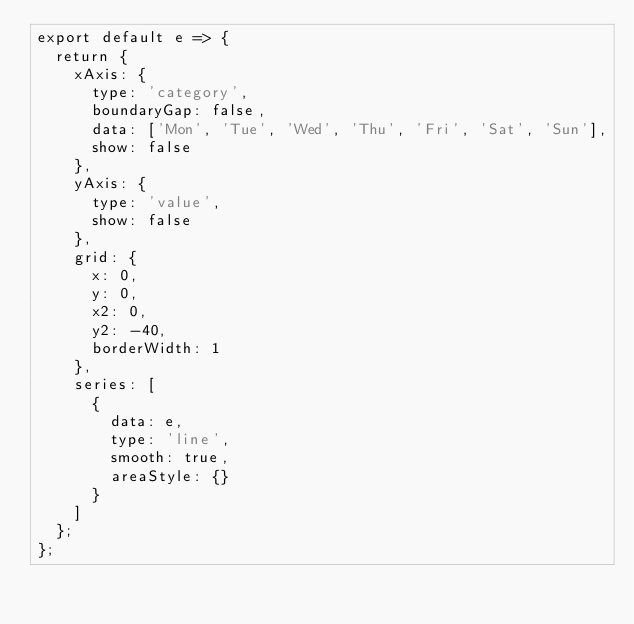Convert code to text. <code><loc_0><loc_0><loc_500><loc_500><_JavaScript_>export default e => {
  return {
    xAxis: {
      type: 'category',
      boundaryGap: false,
      data: ['Mon', 'Tue', 'Wed', 'Thu', 'Fri', 'Sat', 'Sun'],
      show: false
    },
    yAxis: {
      type: 'value',
      show: false
    },
    grid: {
      x: 0,
      y: 0,
      x2: 0,
      y2: -40,
      borderWidth: 1
    },
    series: [
      {
        data: e,
        type: 'line',
        smooth: true,
        areaStyle: {}
      }
    ]
  };
};
</code> 